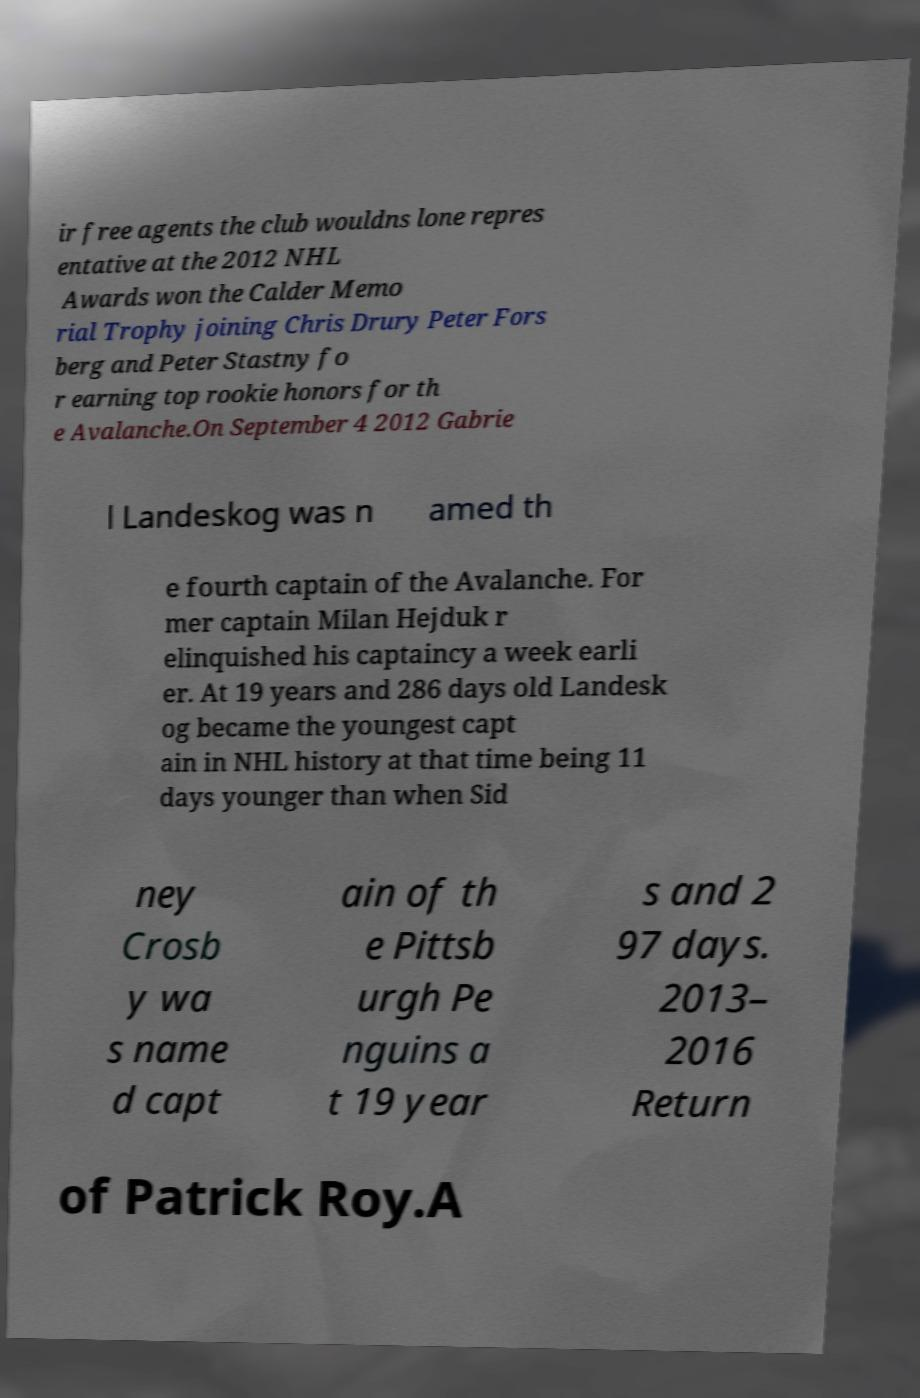What messages or text are displayed in this image? I need them in a readable, typed format. ir free agents the club wouldns lone repres entative at the 2012 NHL Awards won the Calder Memo rial Trophy joining Chris Drury Peter Fors berg and Peter Stastny fo r earning top rookie honors for th e Avalanche.On September 4 2012 Gabrie l Landeskog was n amed th e fourth captain of the Avalanche. For mer captain Milan Hejduk r elinquished his captaincy a week earli er. At 19 years and 286 days old Landesk og became the youngest capt ain in NHL history at that time being 11 days younger than when Sid ney Crosb y wa s name d capt ain of th e Pittsb urgh Pe nguins a t 19 year s and 2 97 days. 2013– 2016 Return of Patrick Roy.A 